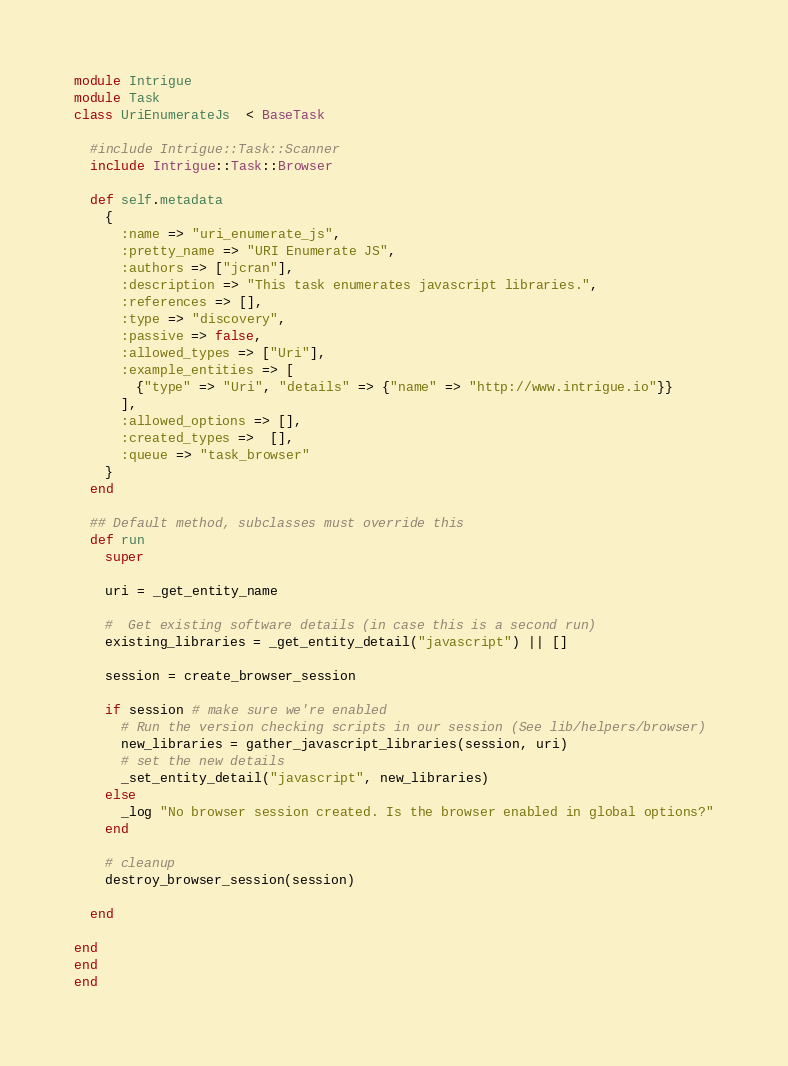Convert code to text. <code><loc_0><loc_0><loc_500><loc_500><_Ruby_>module Intrigue
module Task
class UriEnumerateJs  < BaseTask

  #include Intrigue::Task::Scanner
  include Intrigue::Task::Browser

  def self.metadata
    {
      :name => "uri_enumerate_js",
      :pretty_name => "URI Enumerate JS",
      :authors => ["jcran"],
      :description => "This task enumerates javascript libraries.",
      :references => [],
      :type => "discovery",
      :passive => false,
      :allowed_types => ["Uri"],
      :example_entities => [
        {"type" => "Uri", "details" => {"name" => "http://www.intrigue.io"}}
      ],
      :allowed_options => [],
      :created_types =>  [],
      :queue => "task_browser"
    }
  end

  ## Default method, subclasses must override this
  def run
    super

    uri = _get_entity_name

    #  Get existing software details (in case this is a second run)
    existing_libraries = _get_entity_detail("javascript") || []

    session = create_browser_session

    if session # make sure we're enabled
      # Run the version checking scripts in our session (See lib/helpers/browser)
      new_libraries = gather_javascript_libraries(session, uri)
      # set the new details
      _set_entity_detail("javascript", new_libraries)
    else 
      _log "No browser session created. Is the browser enabled in global options?"
    end

    # cleanup
    destroy_browser_session(session)

  end

end
end
end
</code> 